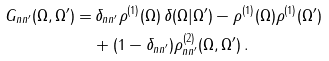Convert formula to latex. <formula><loc_0><loc_0><loc_500><loc_500>G _ { n n ^ { \prime } } ( \Omega , \Omega ^ { \prime } ) = & \, \delta _ { n n ^ { \prime } } \rho ^ { ( 1 ) } ( \Omega ) \, \delta ( \Omega | \Omega ^ { \prime } ) - \rho ^ { ( 1 ) } ( \Omega ) \rho ^ { ( 1 ) } ( \Omega ^ { \prime } ) \\ & + ( 1 - \delta _ { n n ^ { \prime } } ) \rho ^ { ( 2 ) } _ { n n ^ { \prime } } ( \Omega , \Omega ^ { \prime } ) \, .</formula> 